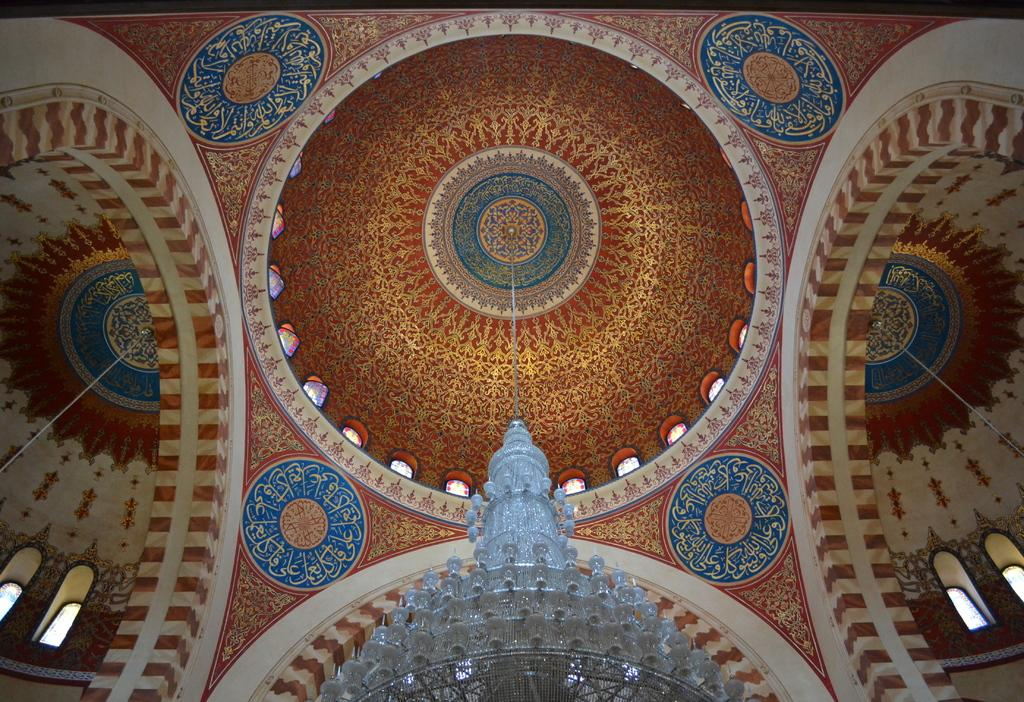What is hanging from the roof in the image? There is a light hanging from the roof in the image. What can be seen above the light in the image? There is a ceiling visible in the background of the image. What is visible through the windows in the background of the image? The windows in the background of the image allow us to see the outside environment. What type of coal is being used to fuel the protest in the image? There is no protest or coal present in the image; it only features a light hanging from the roof and a ceiling visible in the background. 